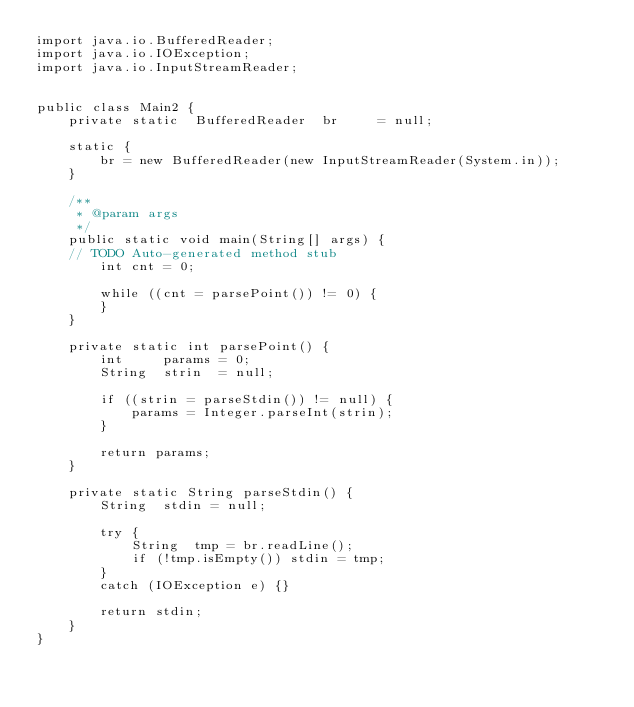<code> <loc_0><loc_0><loc_500><loc_500><_Java_>import java.io.BufferedReader;
import java.io.IOException;
import java.io.InputStreamReader;


public class Main2 {
	private	static	BufferedReader	br     = null;

	static {
		br = new BufferedReader(new InputStreamReader(System.in));
	}
 
    /**
     * @param args
     */
	public static void main(String[] args) {
	// TODO Auto-generated method stub
		int	cnt = 0;

		while ((cnt = parsePoint()) != 0) {
		}
	}
 
	private static int parsePoint() {
		int		params = 0;
        String	strin  = null;

        if ((strin = parseStdin()) != null) {
        	params = Integer.parseInt(strin);
        }
 
        return params;
	}

	private static String parseStdin() {
        String  stdin = null;
        
        try {
        	String  tmp = br.readLine();
        	if (!tmp.isEmpty()) stdin = tmp;
        }
        catch (IOException e) {}
 
        return stdin;
	}
}</code> 